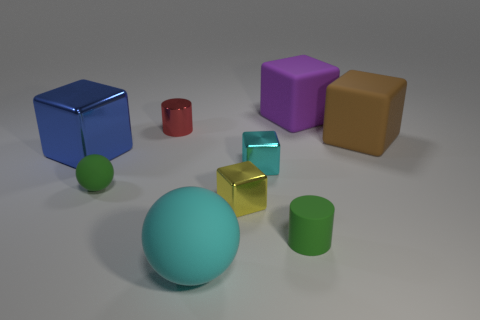Subtract all large shiny cubes. How many cubes are left? 4 Add 1 tiny brown balls. How many objects exist? 10 Subtract all cylinders. How many objects are left? 7 Subtract all red cylinders. How many cylinders are left? 1 Add 7 big purple matte objects. How many big purple matte objects are left? 8 Add 9 small cyan metal things. How many small cyan metal things exist? 10 Subtract 0 purple cylinders. How many objects are left? 9 Subtract all purple blocks. Subtract all red cylinders. How many blocks are left? 4 Subtract all small blue objects. Subtract all blocks. How many objects are left? 4 